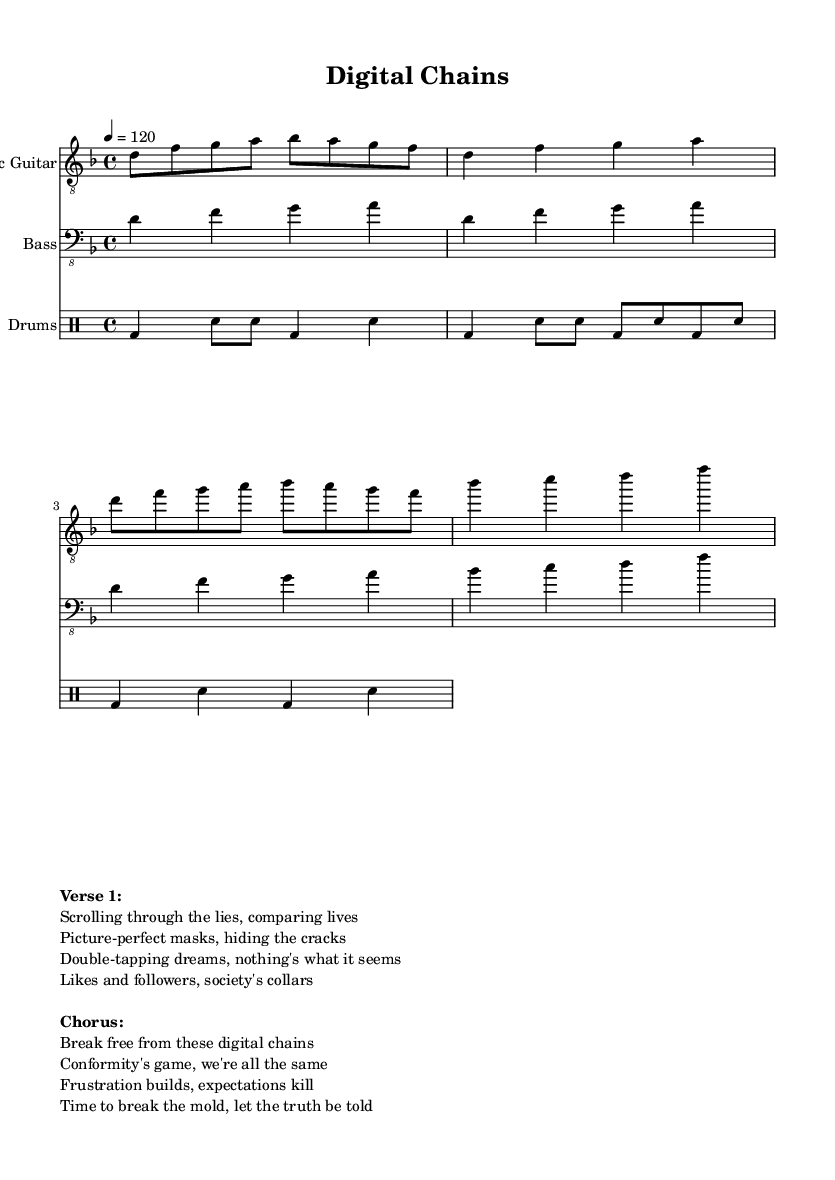What is the key signature of this music? The key signature at the beginning of the sheet music is indicated in the global block, and it shows D minor, which has one flat (B flat).
Answer: D minor What is the time signature of this music? The time signature is indicated in the global block, showing that the piece is written in 4/4 time.
Answer: 4/4 What is the tempo marking for this piece? The tempo marking is also given in the global section of the sheet music, where it states that the tempo is 120 beats per minute.
Answer: 120 How many measures are in the verse section? The verse section consists of two lines of music in the electric guitar part, each having four beats. This totals up to two measures.
Answer: 2 What is the main theme of the chorus? The chorus text refers to breaking free from digital chains and the frustration with conformity, as it expresses a desire for individuality and truth.
Answer: Break free from these digital chains What instruments are used in this piece? The score indicates three parts: Electric Guitar, Bass, and Drums. Each instrument is labeled clearly in the score layout.
Answer: Electric Guitar, Bass, Drums What do the lyrics of the song primarily address? The lyrics focus on feelings of frustration with societal expectations and the superficiality of social media, emphasizing a need for authenticity.
Answer: Frustration with societal expectations 